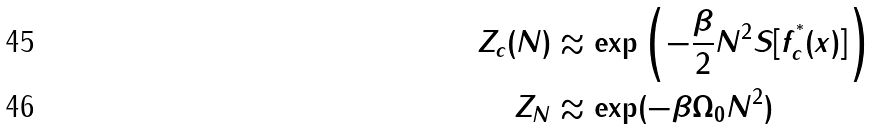Convert formula to latex. <formula><loc_0><loc_0><loc_500><loc_500>Z _ { c } ( N ) & \approx \exp \left ( - \frac { \beta } { 2 } N ^ { 2 } S [ f _ { c } ^ { ^ { * } } ( x ) ] \right ) \\ Z _ { N } & \approx \exp ( - \beta \Omega _ { 0 } N ^ { 2 } )</formula> 